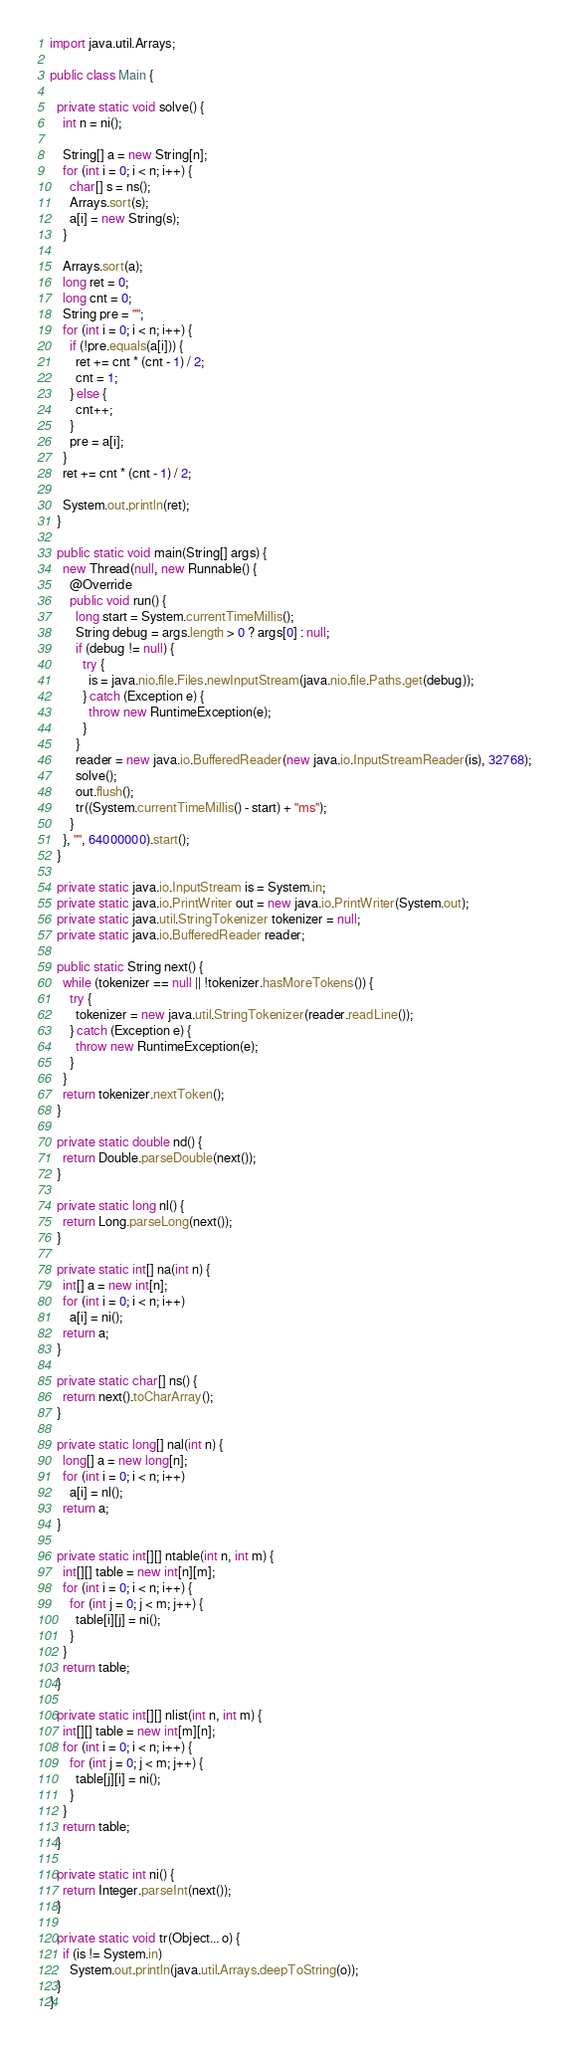Convert code to text. <code><loc_0><loc_0><loc_500><loc_500><_Java_>import java.util.Arrays;

public class Main {

  private static void solve() {
    int n = ni();

    String[] a = new String[n];
    for (int i = 0; i < n; i++) {
      char[] s = ns();
      Arrays.sort(s);
      a[i] = new String(s);
    }

    Arrays.sort(a);
    long ret = 0;
    long cnt = 0;
    String pre = "";
    for (int i = 0; i < n; i++) {
      if (!pre.equals(a[i])) {
        ret += cnt * (cnt - 1) / 2;
        cnt = 1;
      } else {
        cnt++;
      }
      pre = a[i];
    }
    ret += cnt * (cnt - 1) / 2;

    System.out.println(ret);
  }

  public static void main(String[] args) {
    new Thread(null, new Runnable() {
      @Override
      public void run() {
        long start = System.currentTimeMillis();
        String debug = args.length > 0 ? args[0] : null;
        if (debug != null) {
          try {
            is = java.nio.file.Files.newInputStream(java.nio.file.Paths.get(debug));
          } catch (Exception e) {
            throw new RuntimeException(e);
          }
        }
        reader = new java.io.BufferedReader(new java.io.InputStreamReader(is), 32768);
        solve();
        out.flush();
        tr((System.currentTimeMillis() - start) + "ms");
      }
    }, "", 64000000).start();
  }

  private static java.io.InputStream is = System.in;
  private static java.io.PrintWriter out = new java.io.PrintWriter(System.out);
  private static java.util.StringTokenizer tokenizer = null;
  private static java.io.BufferedReader reader;

  public static String next() {
    while (tokenizer == null || !tokenizer.hasMoreTokens()) {
      try {
        tokenizer = new java.util.StringTokenizer(reader.readLine());
      } catch (Exception e) {
        throw new RuntimeException(e);
      }
    }
    return tokenizer.nextToken();
  }

  private static double nd() {
    return Double.parseDouble(next());
  }

  private static long nl() {
    return Long.parseLong(next());
  }

  private static int[] na(int n) {
    int[] a = new int[n];
    for (int i = 0; i < n; i++)
      a[i] = ni();
    return a;
  }

  private static char[] ns() {
    return next().toCharArray();
  }

  private static long[] nal(int n) {
    long[] a = new long[n];
    for (int i = 0; i < n; i++)
      a[i] = nl();
    return a;
  }

  private static int[][] ntable(int n, int m) {
    int[][] table = new int[n][m];
    for (int i = 0; i < n; i++) {
      for (int j = 0; j < m; j++) {
        table[i][j] = ni();
      }
    }
    return table;
  }

  private static int[][] nlist(int n, int m) {
    int[][] table = new int[m][n];
    for (int i = 0; i < n; i++) {
      for (int j = 0; j < m; j++) {
        table[j][i] = ni();
      }
    }
    return table;
  }

  private static int ni() {
    return Integer.parseInt(next());
  }

  private static void tr(Object... o) {
    if (is != System.in)
      System.out.println(java.util.Arrays.deepToString(o));
  }
}

</code> 